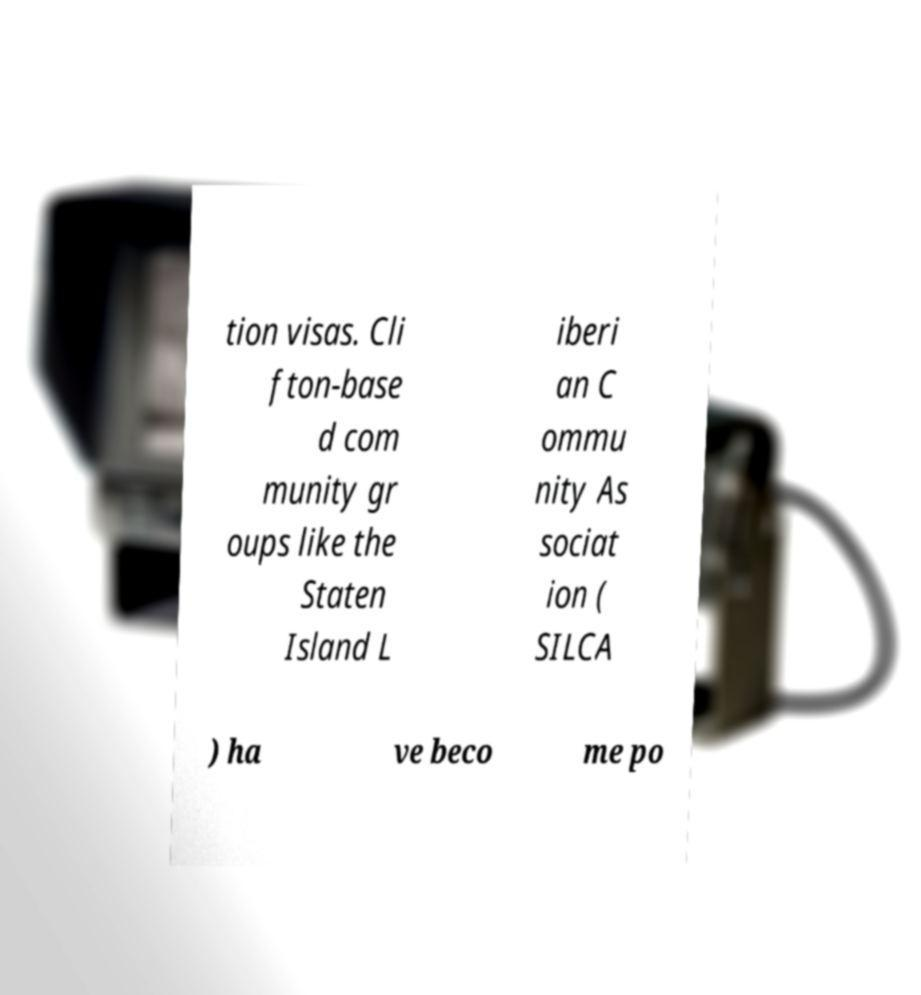Can you accurately transcribe the text from the provided image for me? tion visas. Cli fton-base d com munity gr oups like the Staten Island L iberi an C ommu nity As sociat ion ( SILCA ) ha ve beco me po 